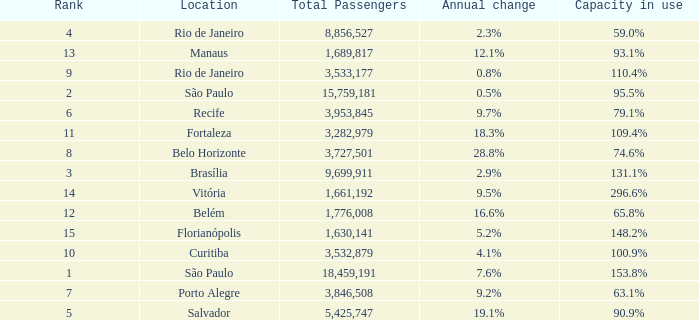What is the sum of Total Passengers when the annual change is 9.7% and the rank is less than 6? None. 